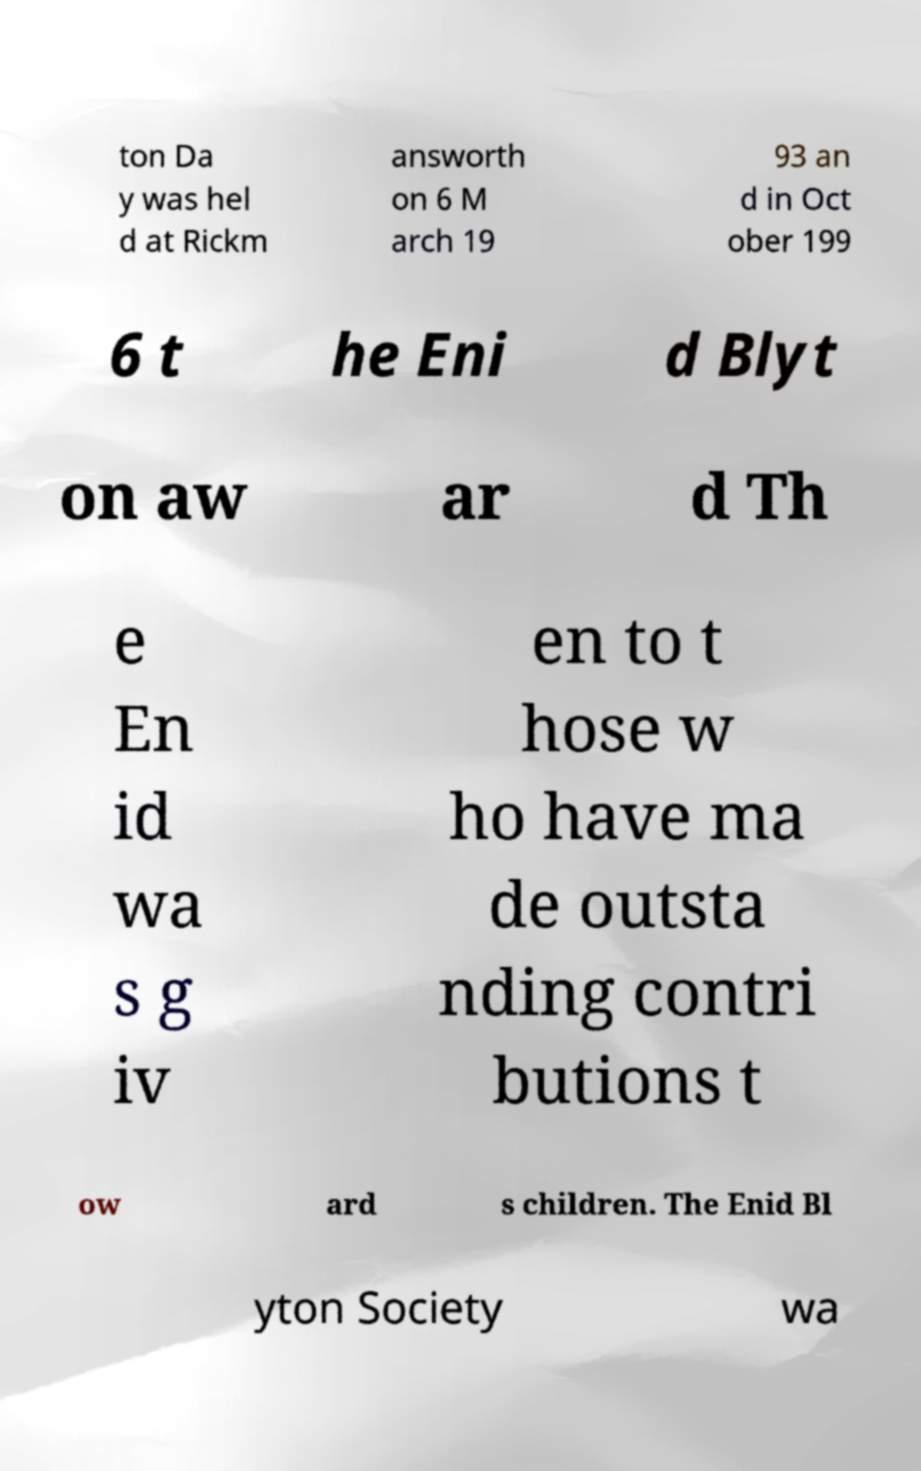What messages or text are displayed in this image? I need them in a readable, typed format. ton Da y was hel d at Rickm answorth on 6 M arch 19 93 an d in Oct ober 199 6 t he Eni d Blyt on aw ar d Th e En id wa s g iv en to t hose w ho have ma de outsta nding contri butions t ow ard s children. The Enid Bl yton Society wa 